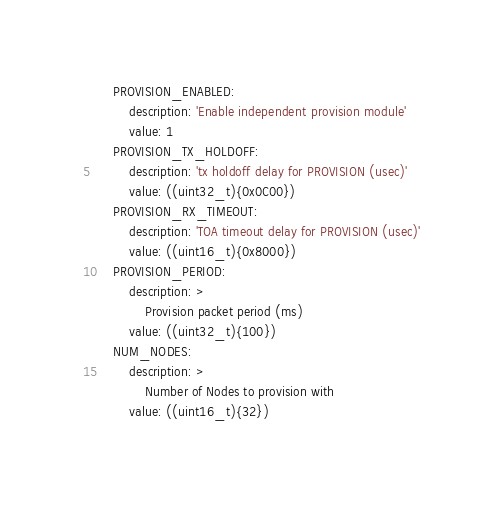<code> <loc_0><loc_0><loc_500><loc_500><_YAML_>    PROVISION_ENABLED:
        description: 'Enable independent provision module'
        value: 1
    PROVISION_TX_HOLDOFF:
        description: 'tx holdoff delay for PROVISION (usec)'
        value: ((uint32_t){0x0C00})
    PROVISION_RX_TIMEOUT:
        description: 'TOA timeout delay for PROVISION (usec)'
        value: ((uint16_t){0x8000})
    PROVISION_PERIOD:
        description: >
            Provision packet period (ms)
        value: ((uint32_t){100})
    NUM_NODES:
        description: >
            Number of Nodes to provision with
        value: ((uint16_t){32})
</code> 